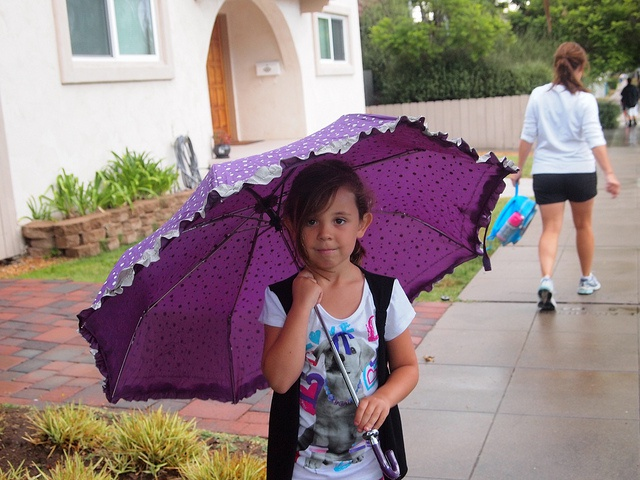Describe the objects in this image and their specific colors. I can see umbrella in white, purple, and black tones, people in white, black, brown, darkgray, and maroon tones, people in white, lavender, black, brown, and tan tones, potted plant in white, tan, gray, and olive tones, and backpack in white, lightblue, gray, and teal tones in this image. 